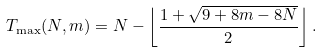Convert formula to latex. <formula><loc_0><loc_0><loc_500><loc_500>T _ { \max } ( N , m ) = N - \left \lfloor \frac { 1 + \sqrt { 9 + 8 m - 8 N } } { 2 } \right \rfloor .</formula> 